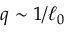Convert formula to latex. <formula><loc_0><loc_0><loc_500><loc_500>q \sim 1 / \ell _ { 0 }</formula> 